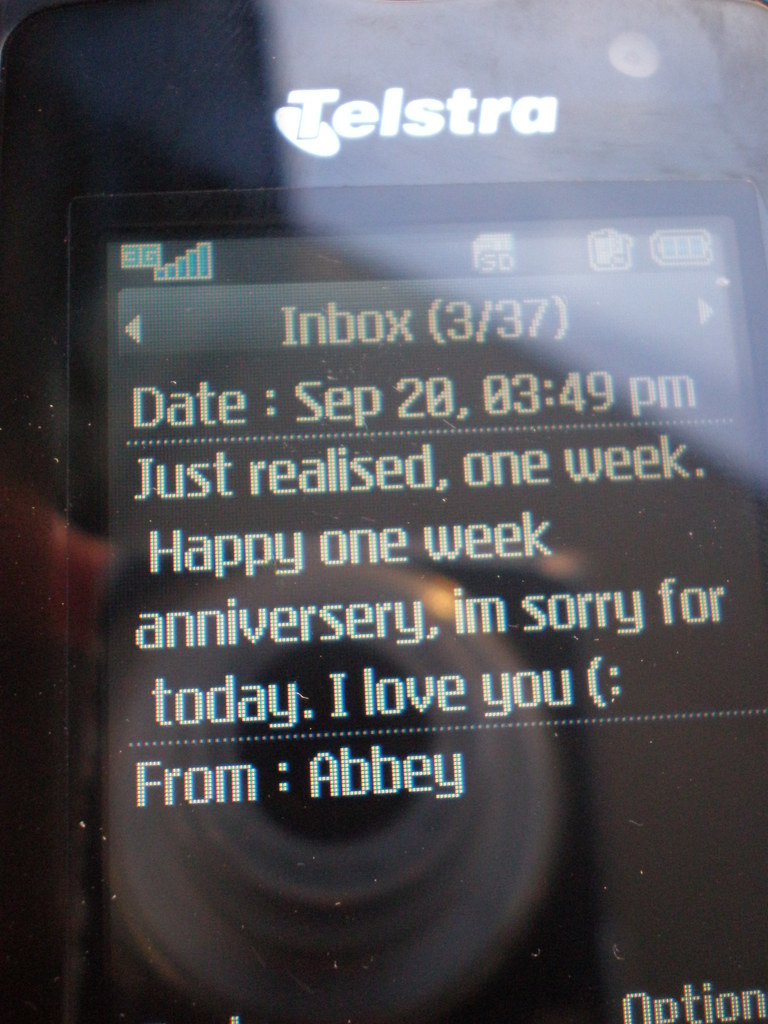What can you infer about the relationship between the sender and recipient from the text message seen in this image? The text message indicates a young relationship as it celebrates a one-week anniversary, involving emotional honesty and intimacy; Abbey's apology and expression of love suggest a caring yet possibly tumultuous early stage of their relationship. 